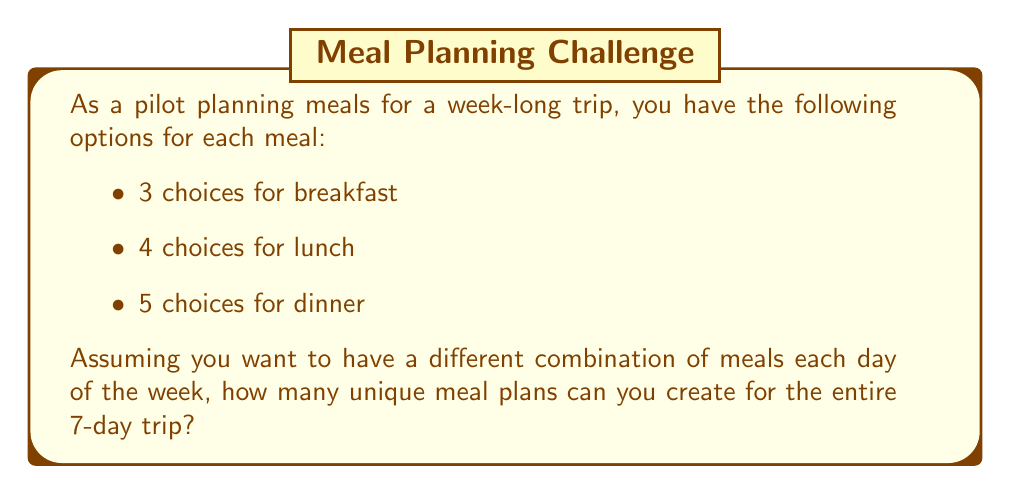Could you help me with this problem? To solve this problem, we'll use the multiplication principle of counting. Here's the step-by-step approach:

1) For each day, we need to choose one breakfast, one lunch, and one dinner.
   - There are 3 choices for breakfast
   - 4 choices for lunch
   - 5 choices for dinner

2) For a single day, the number of possible meal combinations is:
   $3 \times 4 \times 5 = 60$

3) We need to make these choices for each of the 7 days of the trip.

4) Since we want a different combination each day, and the order matters (Day 1's meals are distinct from Day 2's meals, etc.), we can use the multiplication principle again.

5) The total number of possible meal plans for the 7-day trip is:

   $$(3 \times 4 \times 5)^7 = 60^7$$

6) Let's calculate this:
   $$60^7 = 2,176,782,336,000$$

Therefore, there are 2,176,782,336,000 unique meal plans possible for the 7-day trip.
Answer: $$2,176,782,336,000$$ unique meal plans 